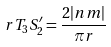<formula> <loc_0><loc_0><loc_500><loc_500>r T _ { 3 } S _ { 2 } ^ { \prime } = \frac { 2 | n m | } { \pi r }</formula> 